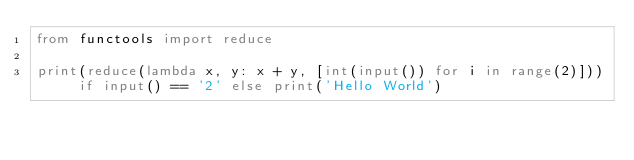Convert code to text. <code><loc_0><loc_0><loc_500><loc_500><_Python_>from functools import reduce

print(reduce(lambda x, y: x + y, [int(input()) for i in range(2)])) if input() == '2' else print('Hello World')</code> 